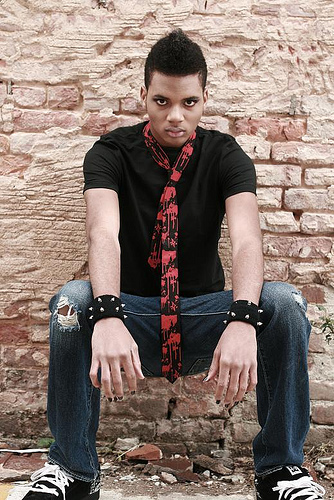How many people are in the picture? 1 